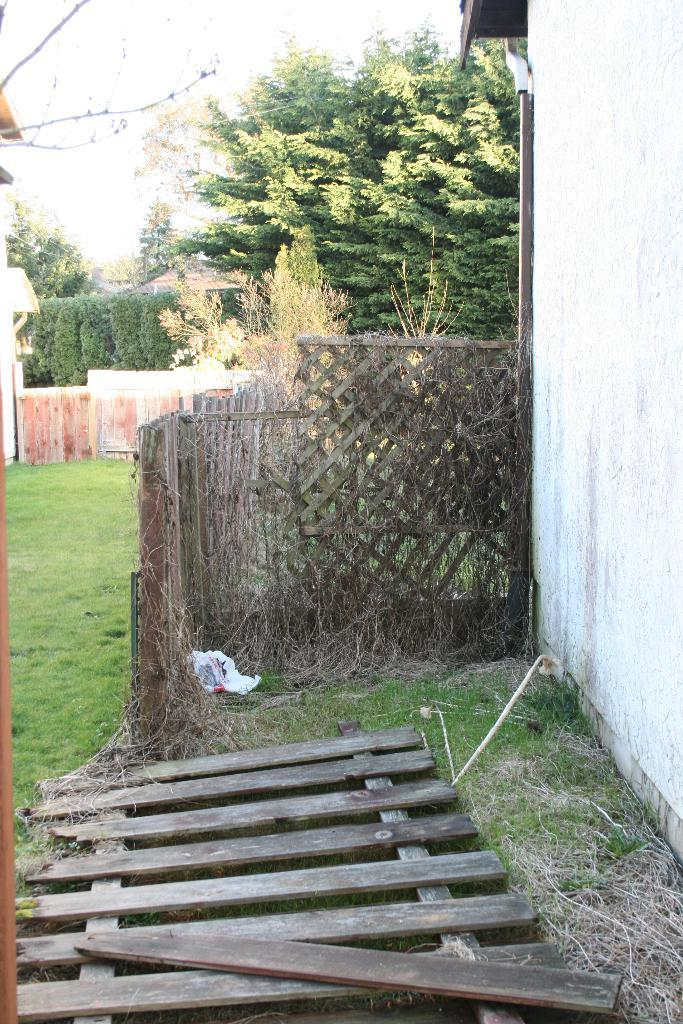What type of fence is visible in the image? There is a wooden fence in the image. What can be seen in the background of the image? There is grass, trees, and houses in the background of the image. How many crows are sitting on the frame in the image? There is no frame or crows present in the image. 